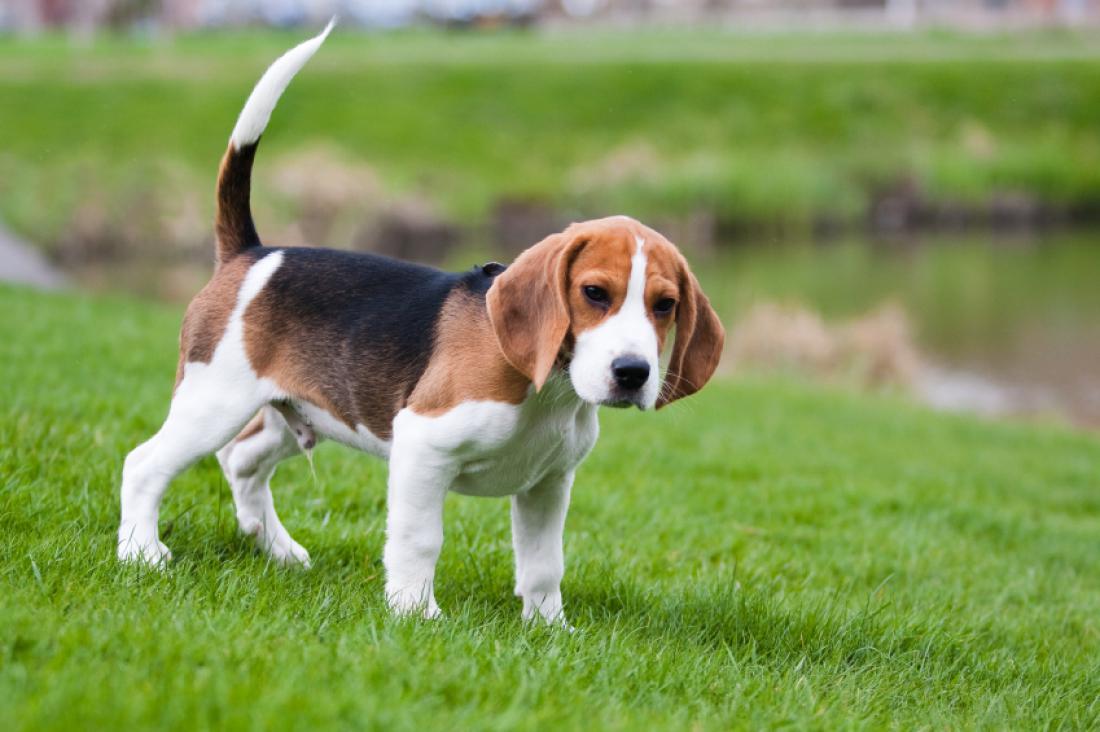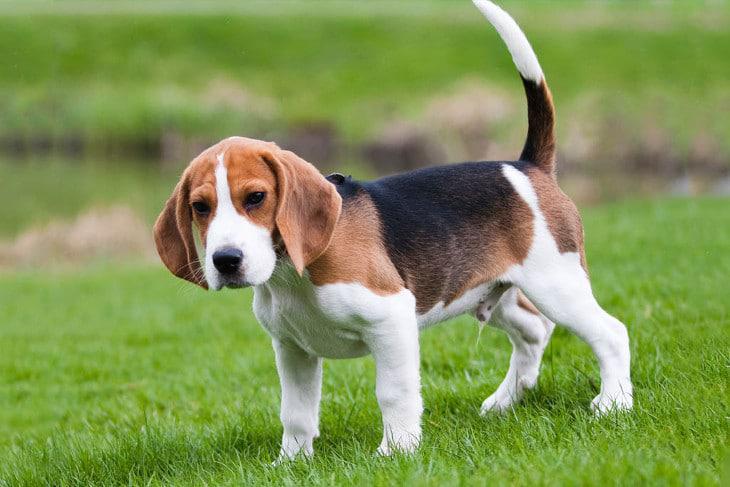The first image is the image on the left, the second image is the image on the right. Given the left and right images, does the statement "An image contains an animal that is not a floppy-eared beagle." hold true? Answer yes or no. No. 